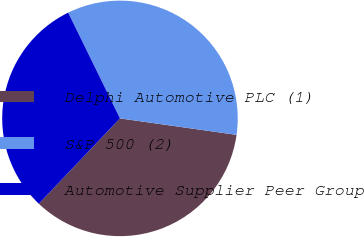Convert chart. <chart><loc_0><loc_0><loc_500><loc_500><pie_chart><fcel>Delphi Automotive PLC (1)<fcel>S&P 500 (2)<fcel>Automotive Supplier Peer Group<nl><fcel>34.87%<fcel>34.48%<fcel>30.65%<nl></chart> 